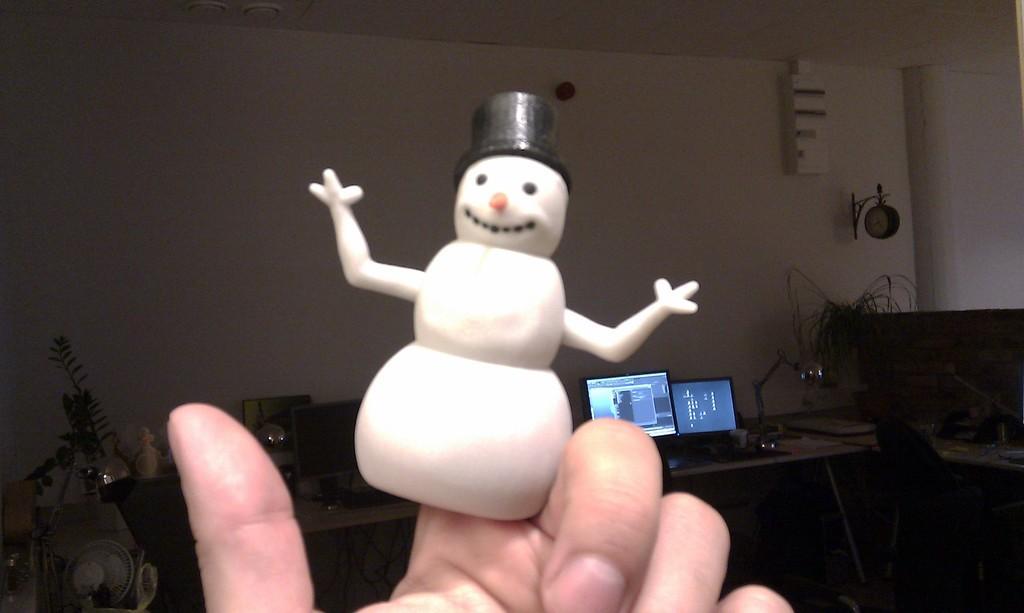Could you give a brief overview of what you see in this image? In this image, we can see a fingerling on the person's hand and in the background, there are monitors, cables, plants, a table fan and some other objects on the table and there is a clock on the wall. 